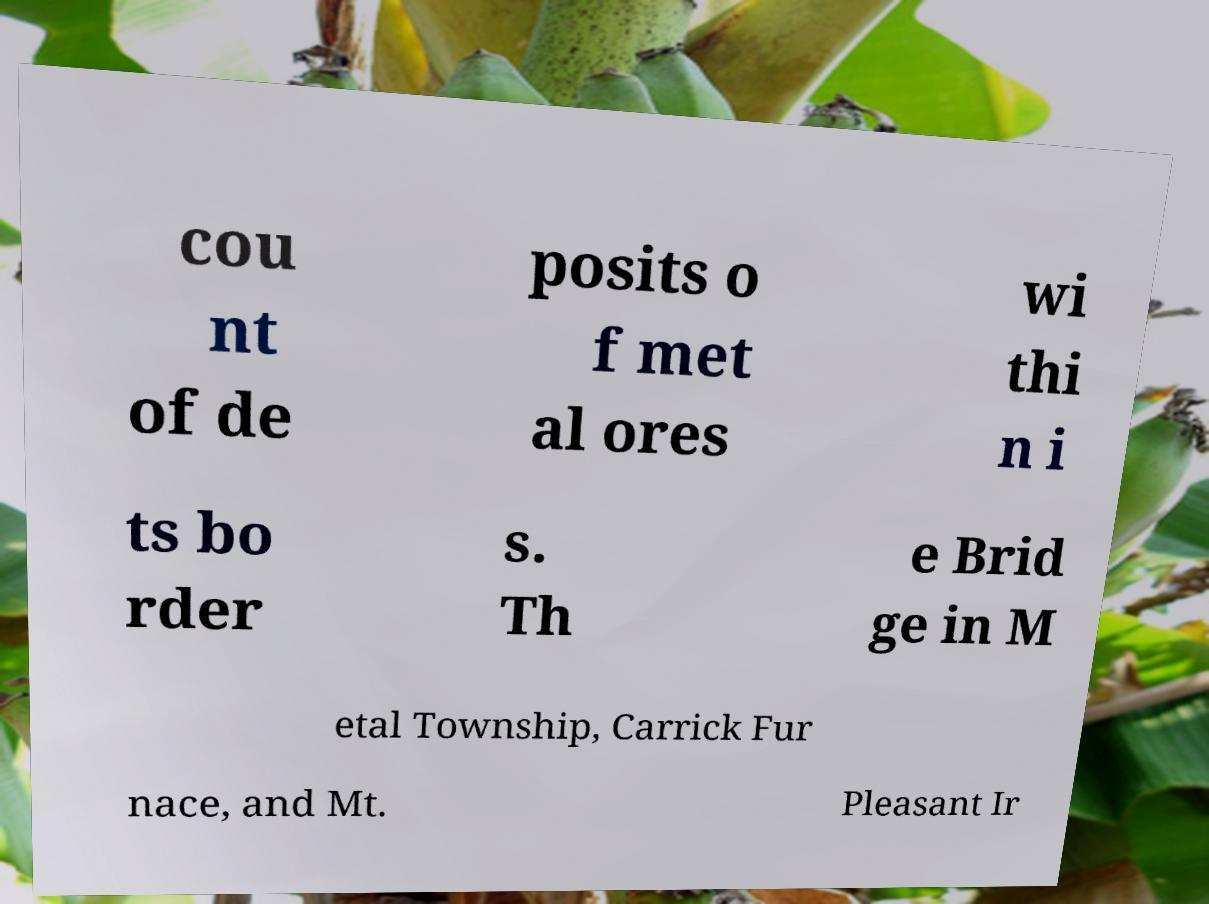Can you accurately transcribe the text from the provided image for me? cou nt of de posits o f met al ores wi thi n i ts bo rder s. Th e Brid ge in M etal Township, Carrick Fur nace, and Mt. Pleasant Ir 